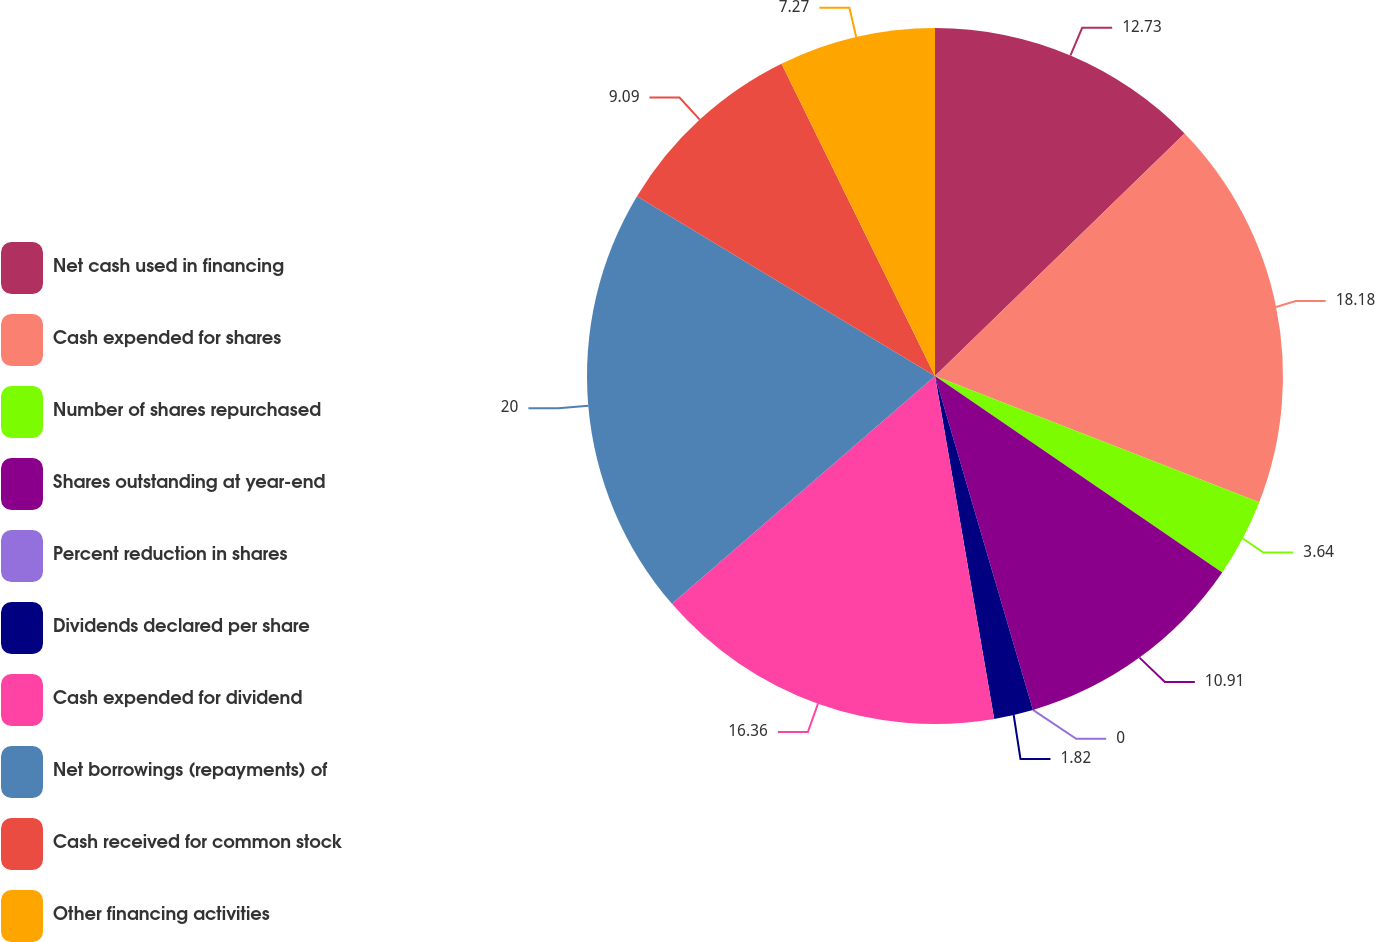Convert chart to OTSL. <chart><loc_0><loc_0><loc_500><loc_500><pie_chart><fcel>Net cash used in financing<fcel>Cash expended for shares<fcel>Number of shares repurchased<fcel>Shares outstanding at year-end<fcel>Percent reduction in shares<fcel>Dividends declared per share<fcel>Cash expended for dividend<fcel>Net borrowings (repayments) of<fcel>Cash received for common stock<fcel>Other financing activities<nl><fcel>12.73%<fcel>18.18%<fcel>3.64%<fcel>10.91%<fcel>0.0%<fcel>1.82%<fcel>16.36%<fcel>20.0%<fcel>9.09%<fcel>7.27%<nl></chart> 